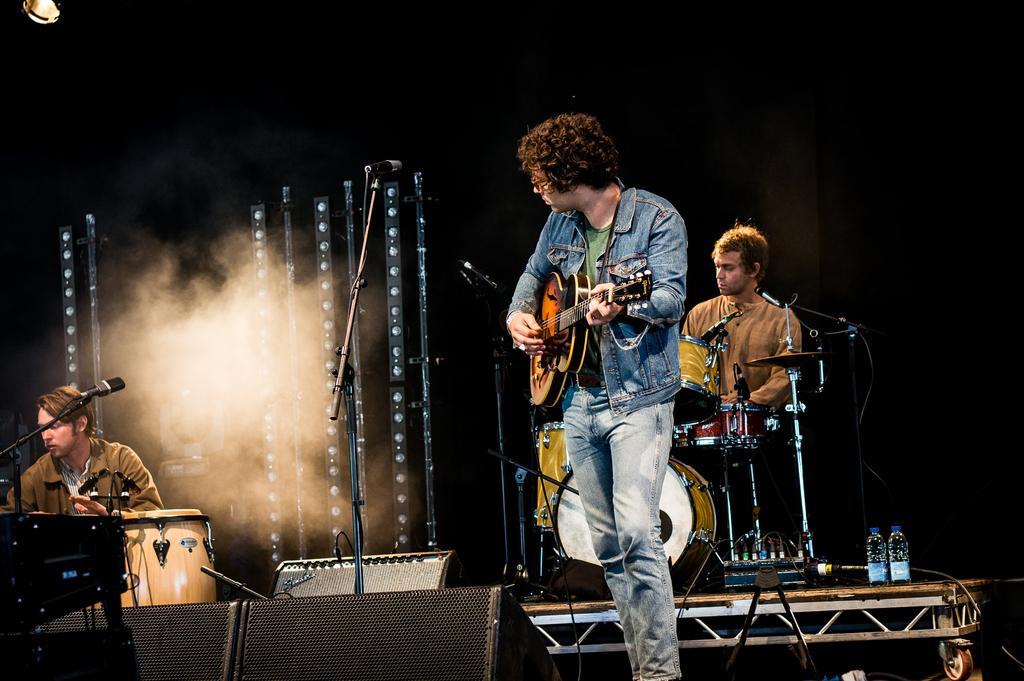How would you summarize this image in a sentence or two? The picture is taken on the stage where three people are present one person is standing in the center of the picture wearing blue jacket and holding guitar behind him there is one person sitting on the chair and playing drums beside him there are water bottles and at the left corner of the picture one is sitting and playing drums behind him there are some stands and smoke. 